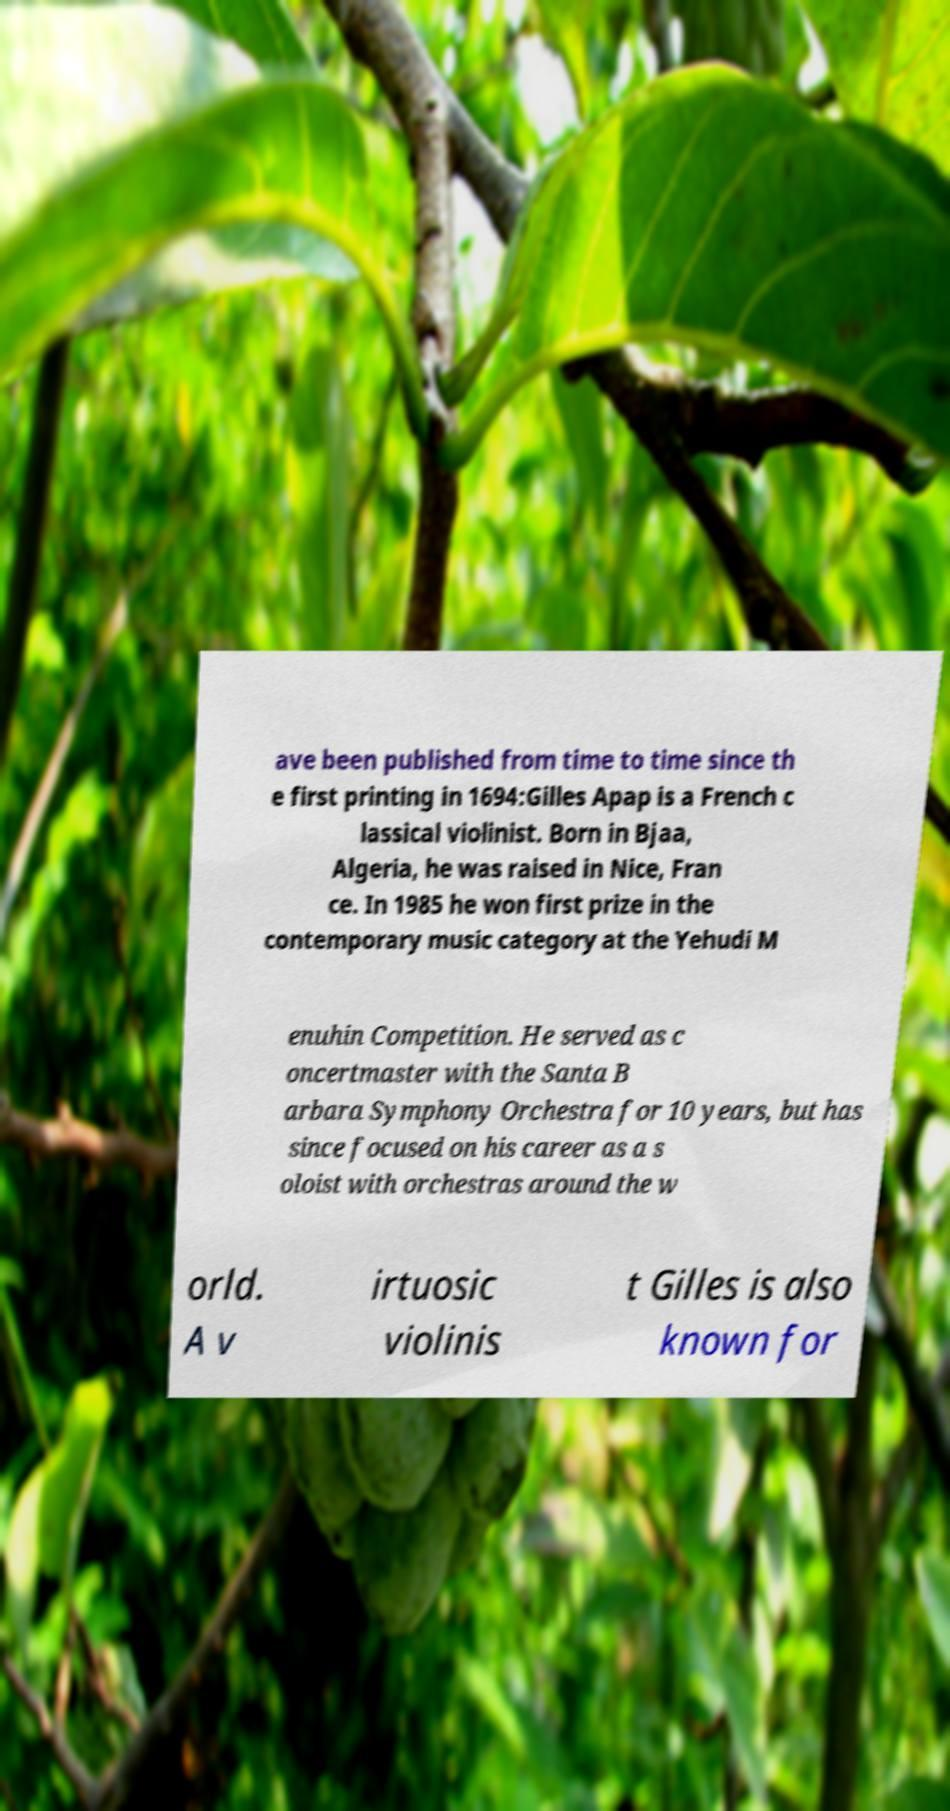Could you assist in decoding the text presented in this image and type it out clearly? ave been published from time to time since th e first printing in 1694:Gilles Apap is a French c lassical violinist. Born in Bjaa, Algeria, he was raised in Nice, Fran ce. In 1985 he won first prize in the contemporary music category at the Yehudi M enuhin Competition. He served as c oncertmaster with the Santa B arbara Symphony Orchestra for 10 years, but has since focused on his career as a s oloist with orchestras around the w orld. A v irtuosic violinis t Gilles is also known for 